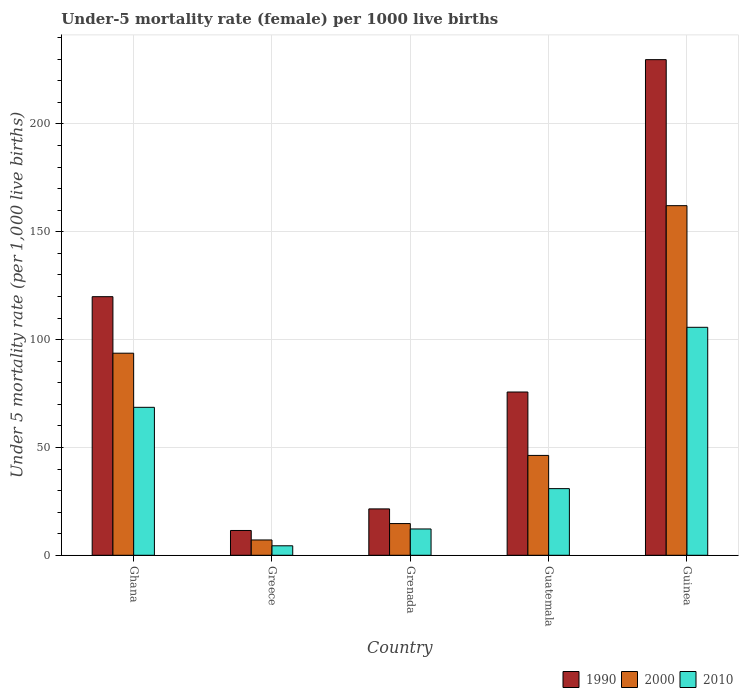How many different coloured bars are there?
Offer a terse response. 3. Are the number of bars per tick equal to the number of legend labels?
Give a very brief answer. Yes. Are the number of bars on each tick of the X-axis equal?
Your answer should be very brief. Yes. How many bars are there on the 4th tick from the left?
Make the answer very short. 3. How many bars are there on the 5th tick from the right?
Make the answer very short. 3. What is the label of the 2nd group of bars from the left?
Offer a terse response. Greece. In how many cases, is the number of bars for a given country not equal to the number of legend labels?
Provide a short and direct response. 0. What is the under-five mortality rate in 1990 in Guatemala?
Make the answer very short. 75.7. Across all countries, what is the maximum under-five mortality rate in 1990?
Provide a succinct answer. 229.8. In which country was the under-five mortality rate in 1990 maximum?
Provide a short and direct response. Guinea. In which country was the under-five mortality rate in 1990 minimum?
Give a very brief answer. Greece. What is the total under-five mortality rate in 2000 in the graph?
Your answer should be compact. 323.9. What is the difference between the under-five mortality rate in 2000 in Greece and that in Guinea?
Offer a terse response. -155. What is the difference between the under-five mortality rate in 2000 in Guinea and the under-five mortality rate in 1990 in Ghana?
Your answer should be compact. 42.2. What is the average under-five mortality rate in 1990 per country?
Provide a short and direct response. 91.68. What is the difference between the under-five mortality rate of/in 2010 and under-five mortality rate of/in 2000 in Grenada?
Offer a terse response. -2.5. In how many countries, is the under-five mortality rate in 2010 greater than 160?
Offer a very short reply. 0. What is the ratio of the under-five mortality rate in 2010 in Ghana to that in Guatemala?
Your answer should be compact. 2.22. Is the under-five mortality rate in 2010 in Grenada less than that in Guatemala?
Provide a short and direct response. Yes. What is the difference between the highest and the second highest under-five mortality rate in 2010?
Your response must be concise. 37.1. What is the difference between the highest and the lowest under-five mortality rate in 2000?
Give a very brief answer. 155. In how many countries, is the under-five mortality rate in 1990 greater than the average under-five mortality rate in 1990 taken over all countries?
Your answer should be very brief. 2. Is it the case that in every country, the sum of the under-five mortality rate in 2010 and under-five mortality rate in 2000 is greater than the under-five mortality rate in 1990?
Your response must be concise. No. Are all the bars in the graph horizontal?
Make the answer very short. No. Are the values on the major ticks of Y-axis written in scientific E-notation?
Provide a succinct answer. No. Does the graph contain any zero values?
Your response must be concise. No. Does the graph contain grids?
Give a very brief answer. Yes. How are the legend labels stacked?
Offer a terse response. Horizontal. What is the title of the graph?
Offer a very short reply. Under-5 mortality rate (female) per 1000 live births. What is the label or title of the X-axis?
Provide a succinct answer. Country. What is the label or title of the Y-axis?
Provide a short and direct response. Under 5 mortality rate (per 1,0 live births). What is the Under 5 mortality rate (per 1,000 live births) in 1990 in Ghana?
Offer a very short reply. 119.9. What is the Under 5 mortality rate (per 1,000 live births) in 2000 in Ghana?
Your response must be concise. 93.7. What is the Under 5 mortality rate (per 1,000 live births) in 2010 in Ghana?
Your response must be concise. 68.6. What is the Under 5 mortality rate (per 1,000 live births) in 2000 in Greece?
Your response must be concise. 7.1. What is the Under 5 mortality rate (per 1,000 live births) of 2010 in Greece?
Your response must be concise. 4.4. What is the Under 5 mortality rate (per 1,000 live births) in 1990 in Grenada?
Offer a very short reply. 21.5. What is the Under 5 mortality rate (per 1,000 live births) in 2000 in Grenada?
Provide a succinct answer. 14.7. What is the Under 5 mortality rate (per 1,000 live births) of 2010 in Grenada?
Your response must be concise. 12.2. What is the Under 5 mortality rate (per 1,000 live births) of 1990 in Guatemala?
Offer a very short reply. 75.7. What is the Under 5 mortality rate (per 1,000 live births) in 2000 in Guatemala?
Keep it short and to the point. 46.3. What is the Under 5 mortality rate (per 1,000 live births) of 2010 in Guatemala?
Ensure brevity in your answer.  30.9. What is the Under 5 mortality rate (per 1,000 live births) in 1990 in Guinea?
Your answer should be compact. 229.8. What is the Under 5 mortality rate (per 1,000 live births) of 2000 in Guinea?
Your answer should be very brief. 162.1. What is the Under 5 mortality rate (per 1,000 live births) in 2010 in Guinea?
Offer a very short reply. 105.7. Across all countries, what is the maximum Under 5 mortality rate (per 1,000 live births) in 1990?
Make the answer very short. 229.8. Across all countries, what is the maximum Under 5 mortality rate (per 1,000 live births) of 2000?
Provide a short and direct response. 162.1. Across all countries, what is the maximum Under 5 mortality rate (per 1,000 live births) of 2010?
Your response must be concise. 105.7. What is the total Under 5 mortality rate (per 1,000 live births) in 1990 in the graph?
Offer a very short reply. 458.4. What is the total Under 5 mortality rate (per 1,000 live births) of 2000 in the graph?
Make the answer very short. 323.9. What is the total Under 5 mortality rate (per 1,000 live births) in 2010 in the graph?
Keep it short and to the point. 221.8. What is the difference between the Under 5 mortality rate (per 1,000 live births) in 1990 in Ghana and that in Greece?
Ensure brevity in your answer.  108.4. What is the difference between the Under 5 mortality rate (per 1,000 live births) in 2000 in Ghana and that in Greece?
Ensure brevity in your answer.  86.6. What is the difference between the Under 5 mortality rate (per 1,000 live births) of 2010 in Ghana and that in Greece?
Provide a succinct answer. 64.2. What is the difference between the Under 5 mortality rate (per 1,000 live births) in 1990 in Ghana and that in Grenada?
Ensure brevity in your answer.  98.4. What is the difference between the Under 5 mortality rate (per 1,000 live births) in 2000 in Ghana and that in Grenada?
Your answer should be compact. 79. What is the difference between the Under 5 mortality rate (per 1,000 live births) of 2010 in Ghana and that in Grenada?
Make the answer very short. 56.4. What is the difference between the Under 5 mortality rate (per 1,000 live births) in 1990 in Ghana and that in Guatemala?
Ensure brevity in your answer.  44.2. What is the difference between the Under 5 mortality rate (per 1,000 live births) of 2000 in Ghana and that in Guatemala?
Offer a very short reply. 47.4. What is the difference between the Under 5 mortality rate (per 1,000 live births) of 2010 in Ghana and that in Guatemala?
Ensure brevity in your answer.  37.7. What is the difference between the Under 5 mortality rate (per 1,000 live births) of 1990 in Ghana and that in Guinea?
Your answer should be very brief. -109.9. What is the difference between the Under 5 mortality rate (per 1,000 live births) of 2000 in Ghana and that in Guinea?
Your answer should be compact. -68.4. What is the difference between the Under 5 mortality rate (per 1,000 live births) of 2010 in Ghana and that in Guinea?
Provide a short and direct response. -37.1. What is the difference between the Under 5 mortality rate (per 1,000 live births) of 2000 in Greece and that in Grenada?
Provide a short and direct response. -7.6. What is the difference between the Under 5 mortality rate (per 1,000 live births) of 2010 in Greece and that in Grenada?
Offer a terse response. -7.8. What is the difference between the Under 5 mortality rate (per 1,000 live births) of 1990 in Greece and that in Guatemala?
Offer a very short reply. -64.2. What is the difference between the Under 5 mortality rate (per 1,000 live births) in 2000 in Greece and that in Guatemala?
Provide a succinct answer. -39.2. What is the difference between the Under 5 mortality rate (per 1,000 live births) of 2010 in Greece and that in Guatemala?
Make the answer very short. -26.5. What is the difference between the Under 5 mortality rate (per 1,000 live births) of 1990 in Greece and that in Guinea?
Provide a succinct answer. -218.3. What is the difference between the Under 5 mortality rate (per 1,000 live births) of 2000 in Greece and that in Guinea?
Give a very brief answer. -155. What is the difference between the Under 5 mortality rate (per 1,000 live births) of 2010 in Greece and that in Guinea?
Offer a very short reply. -101.3. What is the difference between the Under 5 mortality rate (per 1,000 live births) in 1990 in Grenada and that in Guatemala?
Offer a terse response. -54.2. What is the difference between the Under 5 mortality rate (per 1,000 live births) in 2000 in Grenada and that in Guatemala?
Provide a short and direct response. -31.6. What is the difference between the Under 5 mortality rate (per 1,000 live births) of 2010 in Grenada and that in Guatemala?
Ensure brevity in your answer.  -18.7. What is the difference between the Under 5 mortality rate (per 1,000 live births) in 1990 in Grenada and that in Guinea?
Your answer should be compact. -208.3. What is the difference between the Under 5 mortality rate (per 1,000 live births) of 2000 in Grenada and that in Guinea?
Give a very brief answer. -147.4. What is the difference between the Under 5 mortality rate (per 1,000 live births) of 2010 in Grenada and that in Guinea?
Offer a very short reply. -93.5. What is the difference between the Under 5 mortality rate (per 1,000 live births) in 1990 in Guatemala and that in Guinea?
Keep it short and to the point. -154.1. What is the difference between the Under 5 mortality rate (per 1,000 live births) of 2000 in Guatemala and that in Guinea?
Ensure brevity in your answer.  -115.8. What is the difference between the Under 5 mortality rate (per 1,000 live births) in 2010 in Guatemala and that in Guinea?
Ensure brevity in your answer.  -74.8. What is the difference between the Under 5 mortality rate (per 1,000 live births) of 1990 in Ghana and the Under 5 mortality rate (per 1,000 live births) of 2000 in Greece?
Offer a terse response. 112.8. What is the difference between the Under 5 mortality rate (per 1,000 live births) in 1990 in Ghana and the Under 5 mortality rate (per 1,000 live births) in 2010 in Greece?
Keep it short and to the point. 115.5. What is the difference between the Under 5 mortality rate (per 1,000 live births) of 2000 in Ghana and the Under 5 mortality rate (per 1,000 live births) of 2010 in Greece?
Offer a terse response. 89.3. What is the difference between the Under 5 mortality rate (per 1,000 live births) in 1990 in Ghana and the Under 5 mortality rate (per 1,000 live births) in 2000 in Grenada?
Offer a terse response. 105.2. What is the difference between the Under 5 mortality rate (per 1,000 live births) of 1990 in Ghana and the Under 5 mortality rate (per 1,000 live births) of 2010 in Grenada?
Offer a very short reply. 107.7. What is the difference between the Under 5 mortality rate (per 1,000 live births) in 2000 in Ghana and the Under 5 mortality rate (per 1,000 live births) in 2010 in Grenada?
Offer a very short reply. 81.5. What is the difference between the Under 5 mortality rate (per 1,000 live births) of 1990 in Ghana and the Under 5 mortality rate (per 1,000 live births) of 2000 in Guatemala?
Provide a short and direct response. 73.6. What is the difference between the Under 5 mortality rate (per 1,000 live births) of 1990 in Ghana and the Under 5 mortality rate (per 1,000 live births) of 2010 in Guatemala?
Provide a succinct answer. 89. What is the difference between the Under 5 mortality rate (per 1,000 live births) in 2000 in Ghana and the Under 5 mortality rate (per 1,000 live births) in 2010 in Guatemala?
Your answer should be compact. 62.8. What is the difference between the Under 5 mortality rate (per 1,000 live births) of 1990 in Ghana and the Under 5 mortality rate (per 1,000 live births) of 2000 in Guinea?
Make the answer very short. -42.2. What is the difference between the Under 5 mortality rate (per 1,000 live births) in 2000 in Ghana and the Under 5 mortality rate (per 1,000 live births) in 2010 in Guinea?
Your answer should be very brief. -12. What is the difference between the Under 5 mortality rate (per 1,000 live births) of 1990 in Greece and the Under 5 mortality rate (per 1,000 live births) of 2000 in Grenada?
Make the answer very short. -3.2. What is the difference between the Under 5 mortality rate (per 1,000 live births) of 2000 in Greece and the Under 5 mortality rate (per 1,000 live births) of 2010 in Grenada?
Provide a succinct answer. -5.1. What is the difference between the Under 5 mortality rate (per 1,000 live births) of 1990 in Greece and the Under 5 mortality rate (per 1,000 live births) of 2000 in Guatemala?
Provide a short and direct response. -34.8. What is the difference between the Under 5 mortality rate (per 1,000 live births) in 1990 in Greece and the Under 5 mortality rate (per 1,000 live births) in 2010 in Guatemala?
Give a very brief answer. -19.4. What is the difference between the Under 5 mortality rate (per 1,000 live births) in 2000 in Greece and the Under 5 mortality rate (per 1,000 live births) in 2010 in Guatemala?
Keep it short and to the point. -23.8. What is the difference between the Under 5 mortality rate (per 1,000 live births) in 1990 in Greece and the Under 5 mortality rate (per 1,000 live births) in 2000 in Guinea?
Offer a very short reply. -150.6. What is the difference between the Under 5 mortality rate (per 1,000 live births) in 1990 in Greece and the Under 5 mortality rate (per 1,000 live births) in 2010 in Guinea?
Your response must be concise. -94.2. What is the difference between the Under 5 mortality rate (per 1,000 live births) of 2000 in Greece and the Under 5 mortality rate (per 1,000 live births) of 2010 in Guinea?
Offer a very short reply. -98.6. What is the difference between the Under 5 mortality rate (per 1,000 live births) in 1990 in Grenada and the Under 5 mortality rate (per 1,000 live births) in 2000 in Guatemala?
Ensure brevity in your answer.  -24.8. What is the difference between the Under 5 mortality rate (per 1,000 live births) in 1990 in Grenada and the Under 5 mortality rate (per 1,000 live births) in 2010 in Guatemala?
Your response must be concise. -9.4. What is the difference between the Under 5 mortality rate (per 1,000 live births) in 2000 in Grenada and the Under 5 mortality rate (per 1,000 live births) in 2010 in Guatemala?
Ensure brevity in your answer.  -16.2. What is the difference between the Under 5 mortality rate (per 1,000 live births) in 1990 in Grenada and the Under 5 mortality rate (per 1,000 live births) in 2000 in Guinea?
Your answer should be very brief. -140.6. What is the difference between the Under 5 mortality rate (per 1,000 live births) in 1990 in Grenada and the Under 5 mortality rate (per 1,000 live births) in 2010 in Guinea?
Make the answer very short. -84.2. What is the difference between the Under 5 mortality rate (per 1,000 live births) of 2000 in Grenada and the Under 5 mortality rate (per 1,000 live births) of 2010 in Guinea?
Your answer should be very brief. -91. What is the difference between the Under 5 mortality rate (per 1,000 live births) in 1990 in Guatemala and the Under 5 mortality rate (per 1,000 live births) in 2000 in Guinea?
Offer a very short reply. -86.4. What is the difference between the Under 5 mortality rate (per 1,000 live births) in 1990 in Guatemala and the Under 5 mortality rate (per 1,000 live births) in 2010 in Guinea?
Provide a short and direct response. -30. What is the difference between the Under 5 mortality rate (per 1,000 live births) of 2000 in Guatemala and the Under 5 mortality rate (per 1,000 live births) of 2010 in Guinea?
Keep it short and to the point. -59.4. What is the average Under 5 mortality rate (per 1,000 live births) in 1990 per country?
Offer a very short reply. 91.68. What is the average Under 5 mortality rate (per 1,000 live births) of 2000 per country?
Your answer should be very brief. 64.78. What is the average Under 5 mortality rate (per 1,000 live births) in 2010 per country?
Offer a very short reply. 44.36. What is the difference between the Under 5 mortality rate (per 1,000 live births) in 1990 and Under 5 mortality rate (per 1,000 live births) in 2000 in Ghana?
Your response must be concise. 26.2. What is the difference between the Under 5 mortality rate (per 1,000 live births) of 1990 and Under 5 mortality rate (per 1,000 live births) of 2010 in Ghana?
Your answer should be compact. 51.3. What is the difference between the Under 5 mortality rate (per 1,000 live births) of 2000 and Under 5 mortality rate (per 1,000 live births) of 2010 in Ghana?
Make the answer very short. 25.1. What is the difference between the Under 5 mortality rate (per 1,000 live births) in 1990 and Under 5 mortality rate (per 1,000 live births) in 2000 in Greece?
Offer a terse response. 4.4. What is the difference between the Under 5 mortality rate (per 1,000 live births) in 1990 and Under 5 mortality rate (per 1,000 live births) in 2000 in Grenada?
Your response must be concise. 6.8. What is the difference between the Under 5 mortality rate (per 1,000 live births) in 1990 and Under 5 mortality rate (per 1,000 live births) in 2010 in Grenada?
Keep it short and to the point. 9.3. What is the difference between the Under 5 mortality rate (per 1,000 live births) in 1990 and Under 5 mortality rate (per 1,000 live births) in 2000 in Guatemala?
Provide a short and direct response. 29.4. What is the difference between the Under 5 mortality rate (per 1,000 live births) in 1990 and Under 5 mortality rate (per 1,000 live births) in 2010 in Guatemala?
Offer a terse response. 44.8. What is the difference between the Under 5 mortality rate (per 1,000 live births) of 1990 and Under 5 mortality rate (per 1,000 live births) of 2000 in Guinea?
Your answer should be compact. 67.7. What is the difference between the Under 5 mortality rate (per 1,000 live births) in 1990 and Under 5 mortality rate (per 1,000 live births) in 2010 in Guinea?
Your answer should be compact. 124.1. What is the difference between the Under 5 mortality rate (per 1,000 live births) of 2000 and Under 5 mortality rate (per 1,000 live births) of 2010 in Guinea?
Provide a succinct answer. 56.4. What is the ratio of the Under 5 mortality rate (per 1,000 live births) in 1990 in Ghana to that in Greece?
Offer a terse response. 10.43. What is the ratio of the Under 5 mortality rate (per 1,000 live births) in 2000 in Ghana to that in Greece?
Give a very brief answer. 13.2. What is the ratio of the Under 5 mortality rate (per 1,000 live births) in 2010 in Ghana to that in Greece?
Your response must be concise. 15.59. What is the ratio of the Under 5 mortality rate (per 1,000 live births) in 1990 in Ghana to that in Grenada?
Offer a very short reply. 5.58. What is the ratio of the Under 5 mortality rate (per 1,000 live births) of 2000 in Ghana to that in Grenada?
Your answer should be very brief. 6.37. What is the ratio of the Under 5 mortality rate (per 1,000 live births) of 2010 in Ghana to that in Grenada?
Keep it short and to the point. 5.62. What is the ratio of the Under 5 mortality rate (per 1,000 live births) in 1990 in Ghana to that in Guatemala?
Ensure brevity in your answer.  1.58. What is the ratio of the Under 5 mortality rate (per 1,000 live births) in 2000 in Ghana to that in Guatemala?
Give a very brief answer. 2.02. What is the ratio of the Under 5 mortality rate (per 1,000 live births) of 2010 in Ghana to that in Guatemala?
Offer a terse response. 2.22. What is the ratio of the Under 5 mortality rate (per 1,000 live births) of 1990 in Ghana to that in Guinea?
Give a very brief answer. 0.52. What is the ratio of the Under 5 mortality rate (per 1,000 live births) of 2000 in Ghana to that in Guinea?
Your answer should be compact. 0.58. What is the ratio of the Under 5 mortality rate (per 1,000 live births) of 2010 in Ghana to that in Guinea?
Provide a succinct answer. 0.65. What is the ratio of the Under 5 mortality rate (per 1,000 live births) in 1990 in Greece to that in Grenada?
Your answer should be compact. 0.53. What is the ratio of the Under 5 mortality rate (per 1,000 live births) in 2000 in Greece to that in Grenada?
Offer a terse response. 0.48. What is the ratio of the Under 5 mortality rate (per 1,000 live births) in 2010 in Greece to that in Grenada?
Offer a terse response. 0.36. What is the ratio of the Under 5 mortality rate (per 1,000 live births) in 1990 in Greece to that in Guatemala?
Give a very brief answer. 0.15. What is the ratio of the Under 5 mortality rate (per 1,000 live births) in 2000 in Greece to that in Guatemala?
Ensure brevity in your answer.  0.15. What is the ratio of the Under 5 mortality rate (per 1,000 live births) in 2010 in Greece to that in Guatemala?
Your response must be concise. 0.14. What is the ratio of the Under 5 mortality rate (per 1,000 live births) in 2000 in Greece to that in Guinea?
Provide a short and direct response. 0.04. What is the ratio of the Under 5 mortality rate (per 1,000 live births) in 2010 in Greece to that in Guinea?
Offer a terse response. 0.04. What is the ratio of the Under 5 mortality rate (per 1,000 live births) of 1990 in Grenada to that in Guatemala?
Make the answer very short. 0.28. What is the ratio of the Under 5 mortality rate (per 1,000 live births) in 2000 in Grenada to that in Guatemala?
Your answer should be very brief. 0.32. What is the ratio of the Under 5 mortality rate (per 1,000 live births) of 2010 in Grenada to that in Guatemala?
Your answer should be very brief. 0.39. What is the ratio of the Under 5 mortality rate (per 1,000 live births) in 1990 in Grenada to that in Guinea?
Your answer should be very brief. 0.09. What is the ratio of the Under 5 mortality rate (per 1,000 live births) of 2000 in Grenada to that in Guinea?
Your answer should be very brief. 0.09. What is the ratio of the Under 5 mortality rate (per 1,000 live births) in 2010 in Grenada to that in Guinea?
Give a very brief answer. 0.12. What is the ratio of the Under 5 mortality rate (per 1,000 live births) of 1990 in Guatemala to that in Guinea?
Offer a very short reply. 0.33. What is the ratio of the Under 5 mortality rate (per 1,000 live births) in 2000 in Guatemala to that in Guinea?
Provide a short and direct response. 0.29. What is the ratio of the Under 5 mortality rate (per 1,000 live births) of 2010 in Guatemala to that in Guinea?
Keep it short and to the point. 0.29. What is the difference between the highest and the second highest Under 5 mortality rate (per 1,000 live births) of 1990?
Offer a terse response. 109.9. What is the difference between the highest and the second highest Under 5 mortality rate (per 1,000 live births) in 2000?
Offer a terse response. 68.4. What is the difference between the highest and the second highest Under 5 mortality rate (per 1,000 live births) of 2010?
Your answer should be compact. 37.1. What is the difference between the highest and the lowest Under 5 mortality rate (per 1,000 live births) of 1990?
Your answer should be very brief. 218.3. What is the difference between the highest and the lowest Under 5 mortality rate (per 1,000 live births) of 2000?
Provide a succinct answer. 155. What is the difference between the highest and the lowest Under 5 mortality rate (per 1,000 live births) in 2010?
Your answer should be very brief. 101.3. 